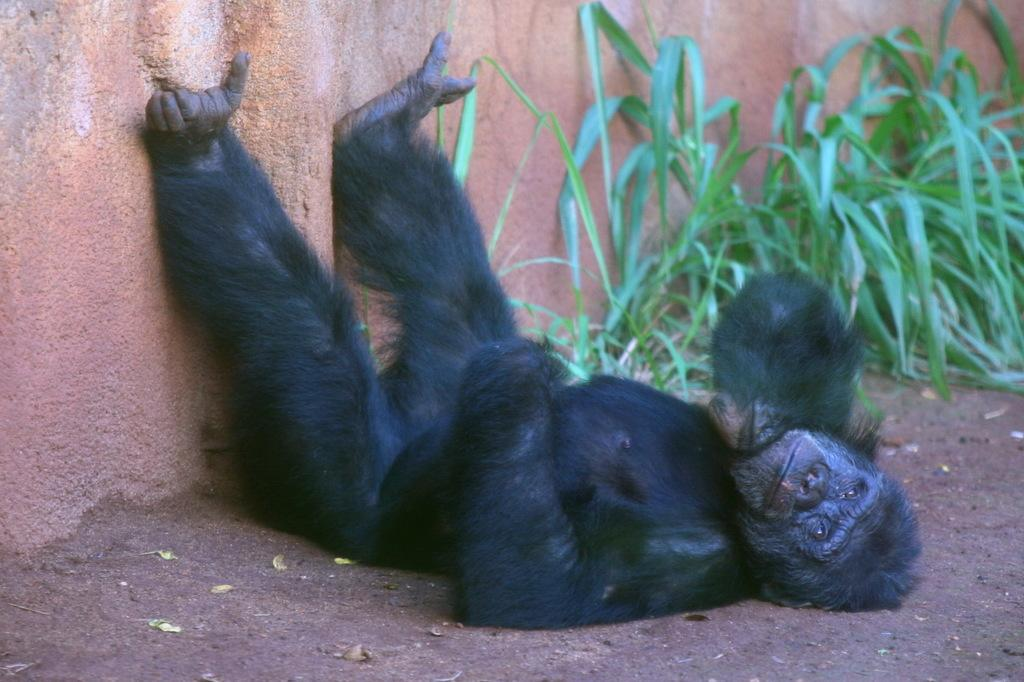What is the gorilla doing in the image? The gorilla is lying on the ground in the image. What is located near the gorilla? There is a wall near the gorilla. What type of vegetation can be seen in the image? There are plants in the image. What substance is the gorilla using to take a bath in the image? There is no indication in the image that the gorilla is taking a bath, and therefore no substance can be identified. 